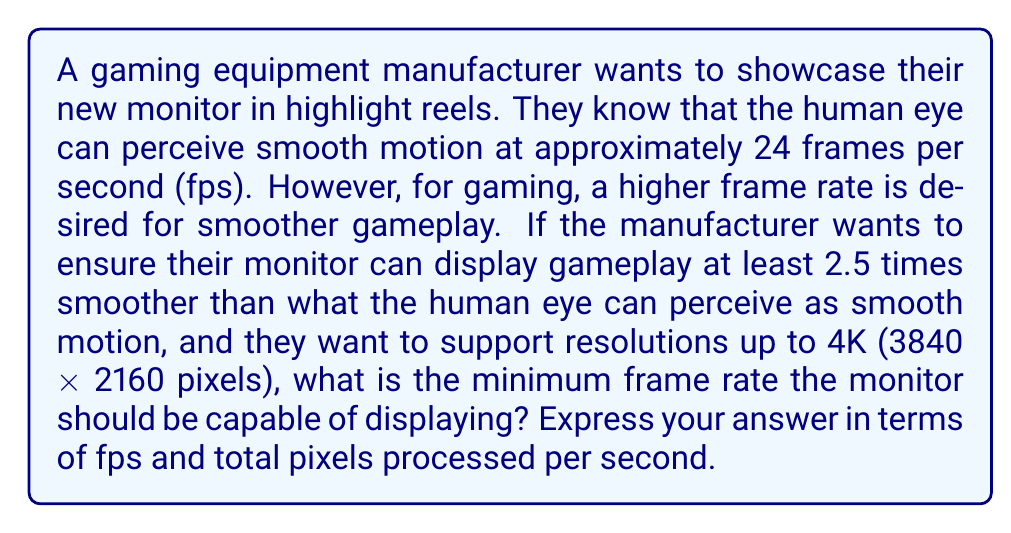Provide a solution to this math problem. To solve this problem, we need to follow these steps:

1. Determine the base frame rate for smooth motion:
   $$ \text{Base fps} = 24 \text{ fps} $$

2. Calculate the desired frame rate for smoother gameplay:
   $$ \text{Desired fps} = 2.5 \times \text{Base fps} $$
   $$ \text{Desired fps} = 2.5 \times 24 = 60 \text{ fps} $$

3. Calculate the total number of pixels in a 4K resolution:
   $$ \text{4K pixels} = 3840 \times 2160 = 8,294,400 \text{ pixels} $$

4. Calculate the total pixels processed per second at the desired frame rate:
   $$ \text{Pixels per second} = \text{Desired fps} \times \text{4K pixels} $$
   $$ \text{Pixels per second} = 60 \times 8,294,400 = 497,664,000 \text{ pixels/second} $$

Therefore, the minimum frame rate the monitor should be capable of displaying is 60 fps, which translates to processing 497,664,000 pixels per second at 4K resolution.
Answer: The minimum frame rate required is 60 fps, processing 497,664,000 pixels per second at 4K resolution. 